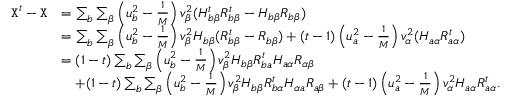Convert formula to latex. <formula><loc_0><loc_0><loc_500><loc_500>\begin{array} { r l } { { X } ^ { t } - { X } } & { = \sum _ { b } \sum _ { \beta } \left ( u _ { b } ^ { 2 } - \frac { 1 } M } \right ) v _ { \beta } ^ { 2 } ( H _ { b \beta } ^ { t } R _ { b \beta } ^ { t } - H _ { b \beta } R _ { b \beta } ) } \\ & { = \sum _ { b } \sum _ { \beta } \left ( u _ { b } ^ { 2 } - \frac { 1 } M } \right ) v _ { \beta } ^ { 2 } H _ { b \beta } ( R _ { b \beta } ^ { t } - R _ { b \beta } ) + ( t - 1 ) \left ( u _ { a } ^ { 2 } - \frac { 1 } M } \right ) v _ { \alpha } ^ { 2 } ( H _ { a \alpha } R _ { a \alpha } ^ { t } ) } \\ & { = ( 1 - t ) \sum _ { b } \sum _ { \beta } \left ( u _ { b } ^ { 2 } - \frac { 1 } M } \right ) v _ { \beta } ^ { 2 } H _ { b \beta } R _ { b a } ^ { t } H _ { a \alpha } R _ { \alpha \beta } } \\ & { + ( 1 - t ) \sum _ { b } \sum _ { \beta } \left ( u _ { b } ^ { 2 } - \frac { 1 } M } \right ) v _ { \beta } ^ { 2 } H _ { b \beta } R _ { b \alpha } ^ { t } H _ { \alpha a } R _ { a \beta } + ( t - 1 ) \left ( u _ { a } ^ { 2 } - \frac { 1 } M } \right ) v _ { \alpha } ^ { 2 } H _ { a \alpha } R _ { a \alpha } ^ { t } . } \end{array}</formula> 